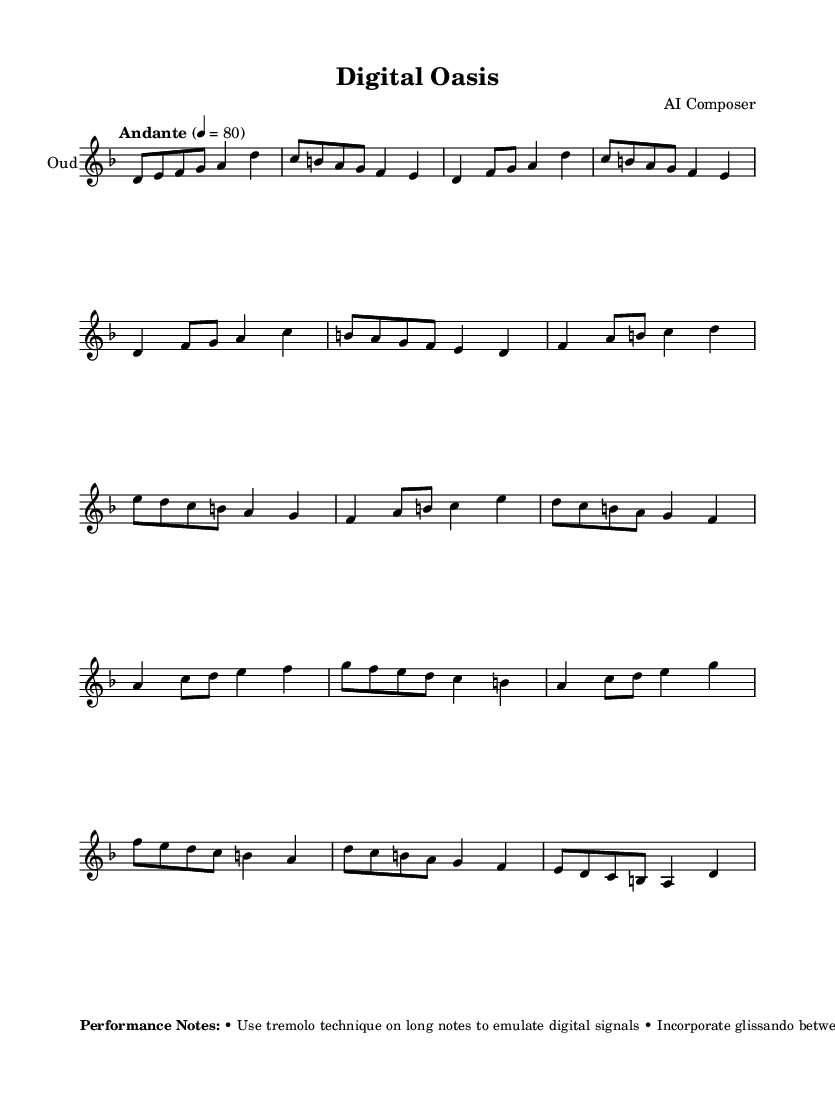What is the key signature of this music? The key signature is indicated at the beginning of the music. The presence of one flat in the key signature corresponds to D minor.
Answer: D minor What is the time signature of this composition? The time signature is shown directly after the key signature at the start of the music. It is marked as 4/4, which means there are four beats per measure.
Answer: 4/4 What is the tempo marking for this piece? The tempo marking is located above the music staff and indicates the speed of the piece. It states "Andante" and a metronome marking of 80 beats per minute.
Answer: Andante, 80 How many sections are there in this composition? By examining the structure of the music, it can be observed that the composition is divided into three main sections: A, B, and C, plus an intro and an outro.
Answer: Five What performance technique is suggested for long notes? The performance notes detail specific techniques to use during the piece. In the notes, it is stated to use tremolo technique on long notes to mimic digital signals.
Answer: Tremolo What is a suggested effect to represent typing sounds in this composition? The performance notes describe techniques to create specific sounds. It suggests experimenting with muted strings to generate percussive effects that mimic the sound of typing.
Answer: Muted strings What musical characteristic distinguishes the Middle Eastern flavor in this piece? The performance notes mention that trills and mordents are to be applied sparingly, which are characteristics of Middle Eastern music.
Answer: Trills and mordents 